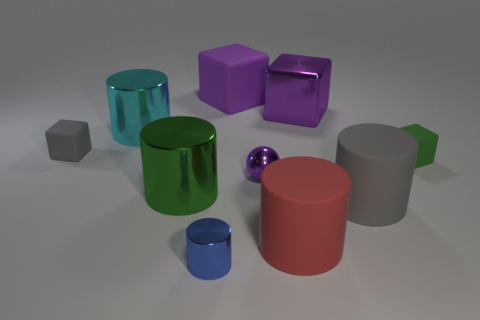What is the material of the other big block that is the same color as the large metallic block?
Keep it short and to the point. Rubber. Do the tiny cube that is to the left of the tiny blue object and the tiny blue cylinder have the same material?
Your response must be concise. No. Are the large cylinder in front of the gray cylinder and the cyan cylinder that is left of the small blue metal object made of the same material?
Offer a very short reply. No. Do the big rubber block and the big metallic thing that is to the right of the green shiny object have the same color?
Ensure brevity in your answer.  Yes. What is the material of the gray object to the left of the large cyan metallic object that is behind the red matte thing?
Offer a very short reply. Rubber. What number of shiny cubes have the same color as the small metal sphere?
Ensure brevity in your answer.  1. What number of cylinders are to the right of the cyan metal thing and behind the green matte thing?
Offer a very short reply. 0. Do the large matte thing behind the small purple metal object and the shiny ball that is in front of the metal block have the same color?
Offer a very short reply. Yes. There is a green thing that is the same shape as the big gray object; what is its size?
Make the answer very short. Large. Are there any gray objects to the right of the tiny purple object?
Give a very brief answer. Yes. 